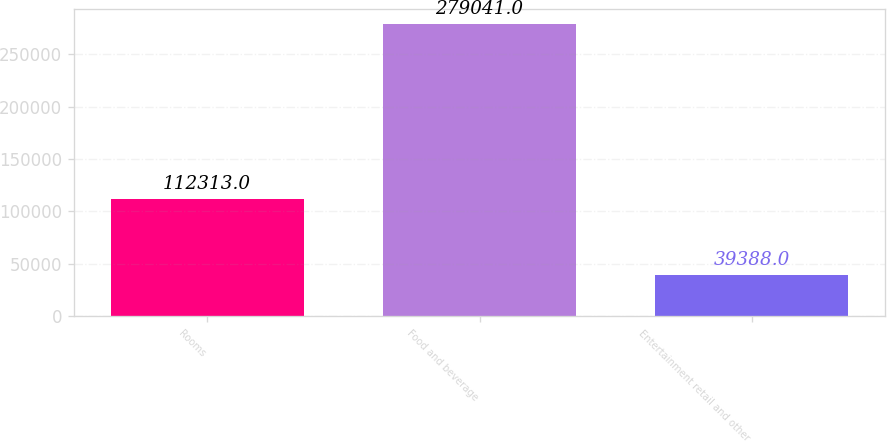Convert chart. <chart><loc_0><loc_0><loc_500><loc_500><bar_chart><fcel>Rooms<fcel>Food and beverage<fcel>Entertainment retail and other<nl><fcel>112313<fcel>279041<fcel>39388<nl></chart> 